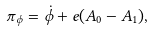<formula> <loc_0><loc_0><loc_500><loc_500>\pi _ { \phi } = \dot { \phi } + e ( A _ { 0 } - A _ { 1 } ) ,</formula> 